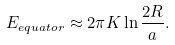<formula> <loc_0><loc_0><loc_500><loc_500>E _ { e q u a t o r } \approx 2 \pi K \ln \frac { 2 R } { a } .</formula> 